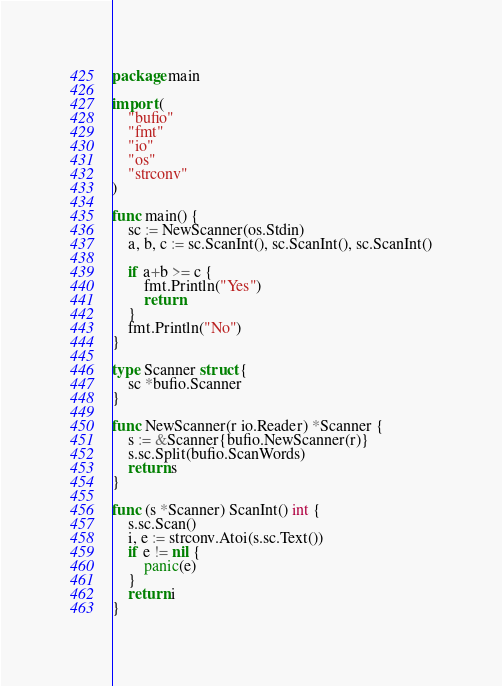Convert code to text. <code><loc_0><loc_0><loc_500><loc_500><_Go_>package main

import (
	"bufio"
	"fmt"
	"io"
	"os"
	"strconv"
)

func main() {
	sc := NewScanner(os.Stdin)
	a, b, c := sc.ScanInt(), sc.ScanInt(), sc.ScanInt()

	if a+b >= c {
		fmt.Println("Yes")
		return
	}
	fmt.Println("No")
}

type Scanner struct {
	sc *bufio.Scanner
}

func NewScanner(r io.Reader) *Scanner {
	s := &Scanner{bufio.NewScanner(r)}
	s.sc.Split(bufio.ScanWords)
	return s
}

func (s *Scanner) ScanInt() int {
	s.sc.Scan()
	i, e := strconv.Atoi(s.sc.Text())
	if e != nil {
		panic(e)
	}
	return i
}
</code> 